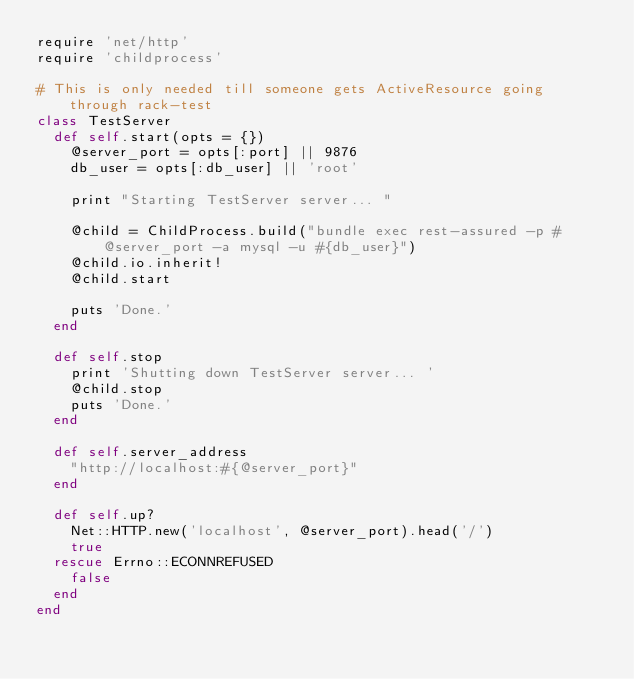<code> <loc_0><loc_0><loc_500><loc_500><_Ruby_>require 'net/http'
require 'childprocess'

# This is only needed till someone gets ActiveResource going through rack-test
class TestServer
  def self.start(opts = {})
    @server_port = opts[:port] || 9876
    db_user = opts[:db_user] || 'root'

    print "Starting TestServer server... "

    @child = ChildProcess.build("bundle exec rest-assured -p #@server_port -a mysql -u #{db_user}")
    @child.io.inherit!
    @child.start

    puts 'Done.'
  end

  def self.stop
    print 'Shutting down TestServer server... '
    @child.stop
    puts 'Done.'
  end

  def self.server_address
    "http://localhost:#{@server_port}"
  end

  def self.up?
    Net::HTTP.new('localhost', @server_port).head('/')
    true
  rescue Errno::ECONNREFUSED
    false
  end
end
</code> 